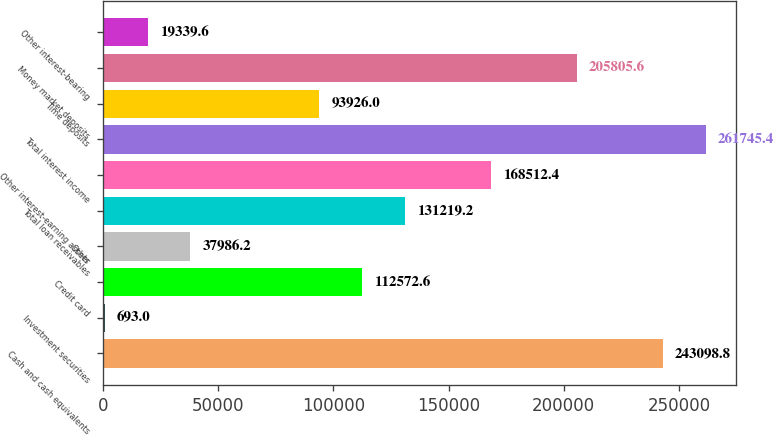Convert chart. <chart><loc_0><loc_0><loc_500><loc_500><bar_chart><fcel>Cash and cash equivalents<fcel>Investment securities<fcel>Credit card<fcel>Other<fcel>Total loan receivables<fcel>Other interest-earning assets<fcel>Total interest income<fcel>Time deposits<fcel>Money market deposits<fcel>Other interest-bearing<nl><fcel>243099<fcel>693<fcel>112573<fcel>37986.2<fcel>131219<fcel>168512<fcel>261745<fcel>93926<fcel>205806<fcel>19339.6<nl></chart> 